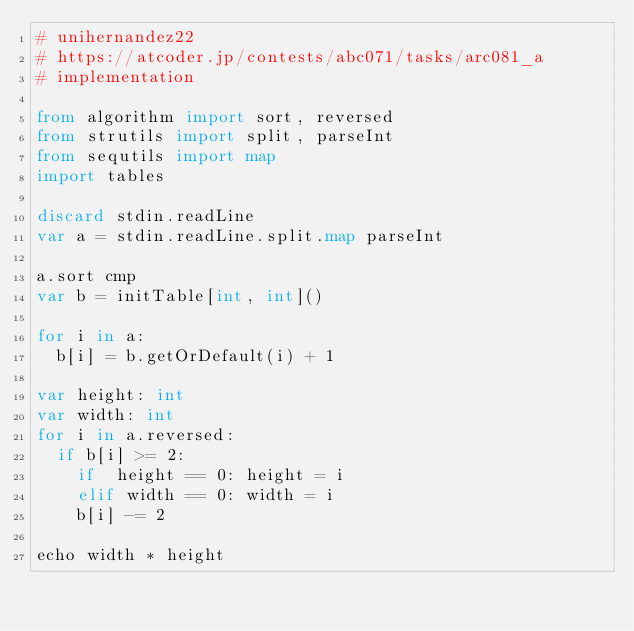Convert code to text. <code><loc_0><loc_0><loc_500><loc_500><_Nim_># unihernandez22
# https://atcoder.jp/contests/abc071/tasks/arc081_a
# implementation

from algorithm import sort, reversed
from strutils import split, parseInt
from sequtils import map
import tables

discard stdin.readLine
var a = stdin.readLine.split.map parseInt

a.sort cmp
var b = initTable[int, int]()

for i in a:
  b[i] = b.getOrDefault(i) + 1

var height: int
var width: int
for i in a.reversed:
  if b[i] >= 2:
    if  height == 0: height = i
    elif width == 0: width = i
    b[i] -= 2

echo width * height

</code> 